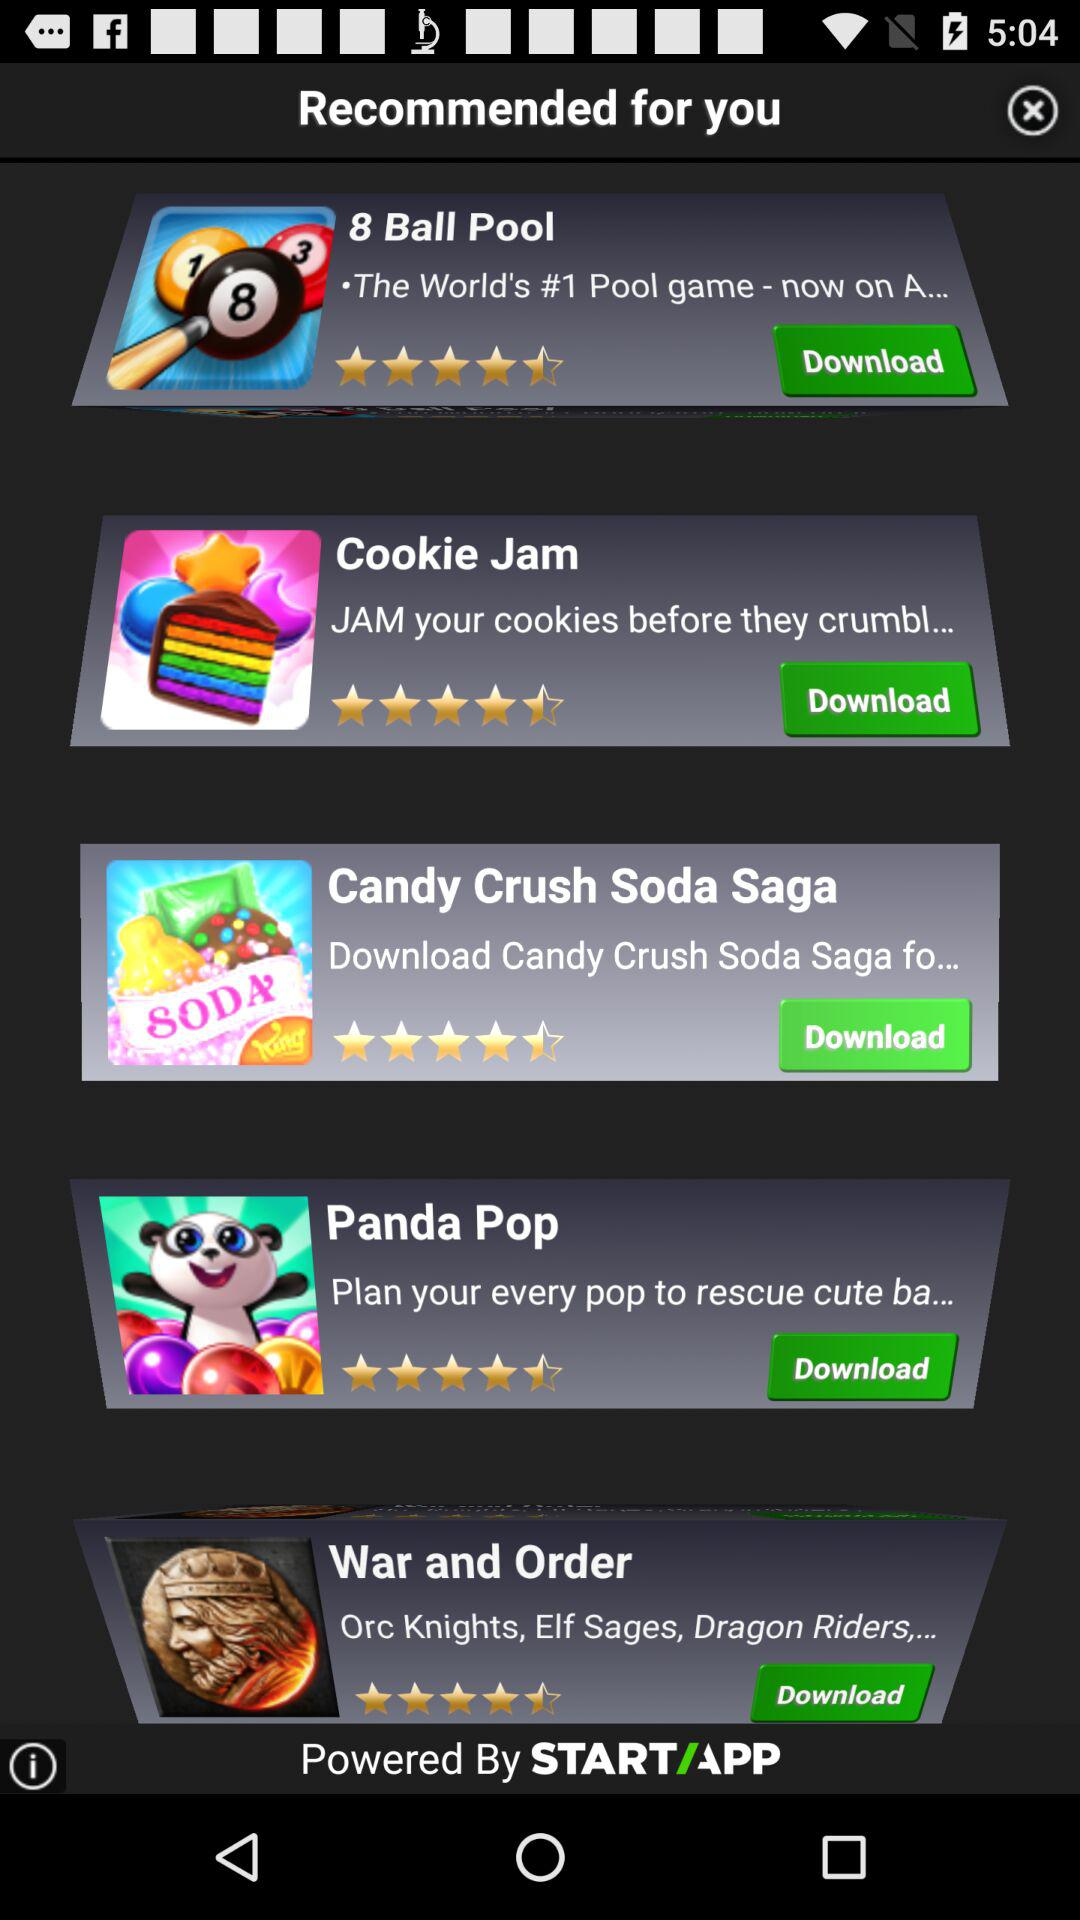What is the star rating for the "Candy Crush Soda Saga"? The star rating is 4.5 stars. 